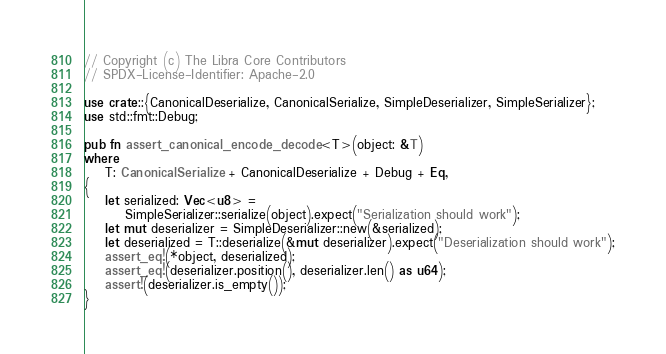Convert code to text. <code><loc_0><loc_0><loc_500><loc_500><_Rust_>// Copyright (c) The Libra Core Contributors
// SPDX-License-Identifier: Apache-2.0

use crate::{CanonicalDeserialize, CanonicalSerialize, SimpleDeserializer, SimpleSerializer};
use std::fmt::Debug;

pub fn assert_canonical_encode_decode<T>(object: &T)
where
    T: CanonicalSerialize + CanonicalDeserialize + Debug + Eq,
{
    let serialized: Vec<u8> =
        SimpleSerializer::serialize(object).expect("Serialization should work");
    let mut deserializer = SimpleDeserializer::new(&serialized);
    let deserialized = T::deserialize(&mut deserializer).expect("Deserialization should work");
    assert_eq!(*object, deserialized);
    assert_eq!(deserializer.position(), deserializer.len() as u64);
    assert!(deserializer.is_empty());
}
</code> 